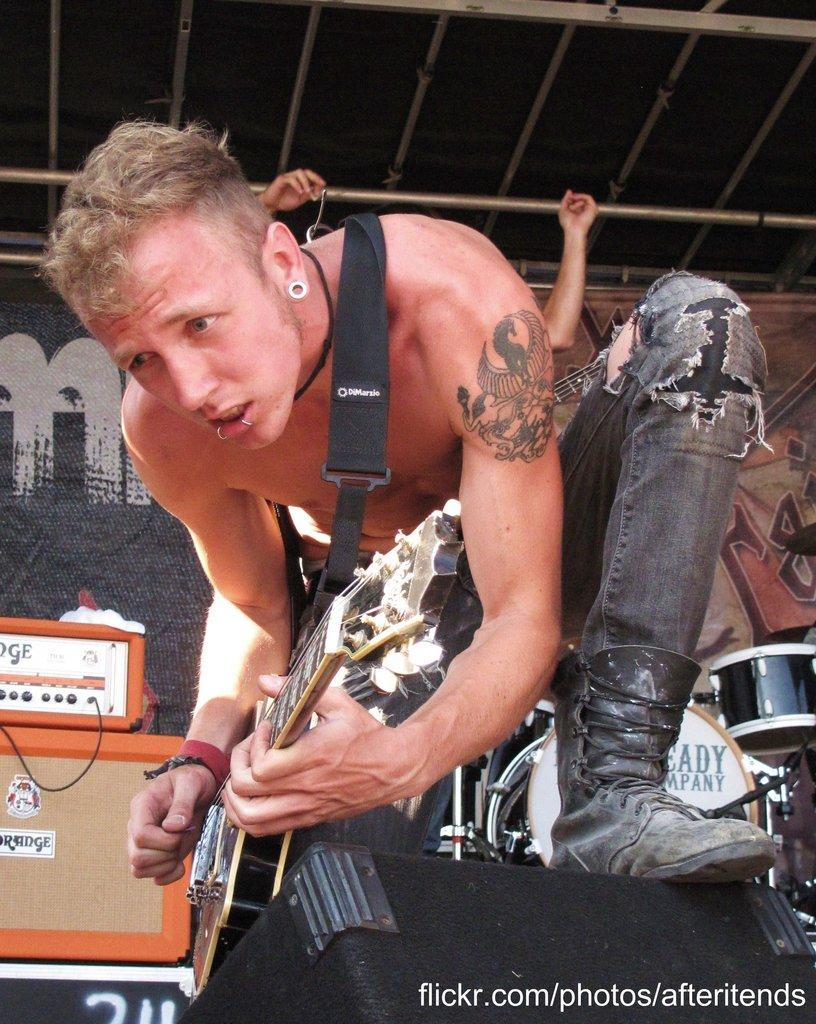What is the main subject of the image? The main subject of the image is a man. What is the man doing in the image? The man is kneeling and playing a guitar. Who is the owner of the sink in the image? There is no sink present in the image, so it is not possible to determine the owner. 